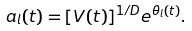<formula> <loc_0><loc_0><loc_500><loc_500>a _ { l } ( t ) = [ V ( t ) ] ^ { 1 / D } e ^ { \theta _ { l } ( t ) } .</formula> 